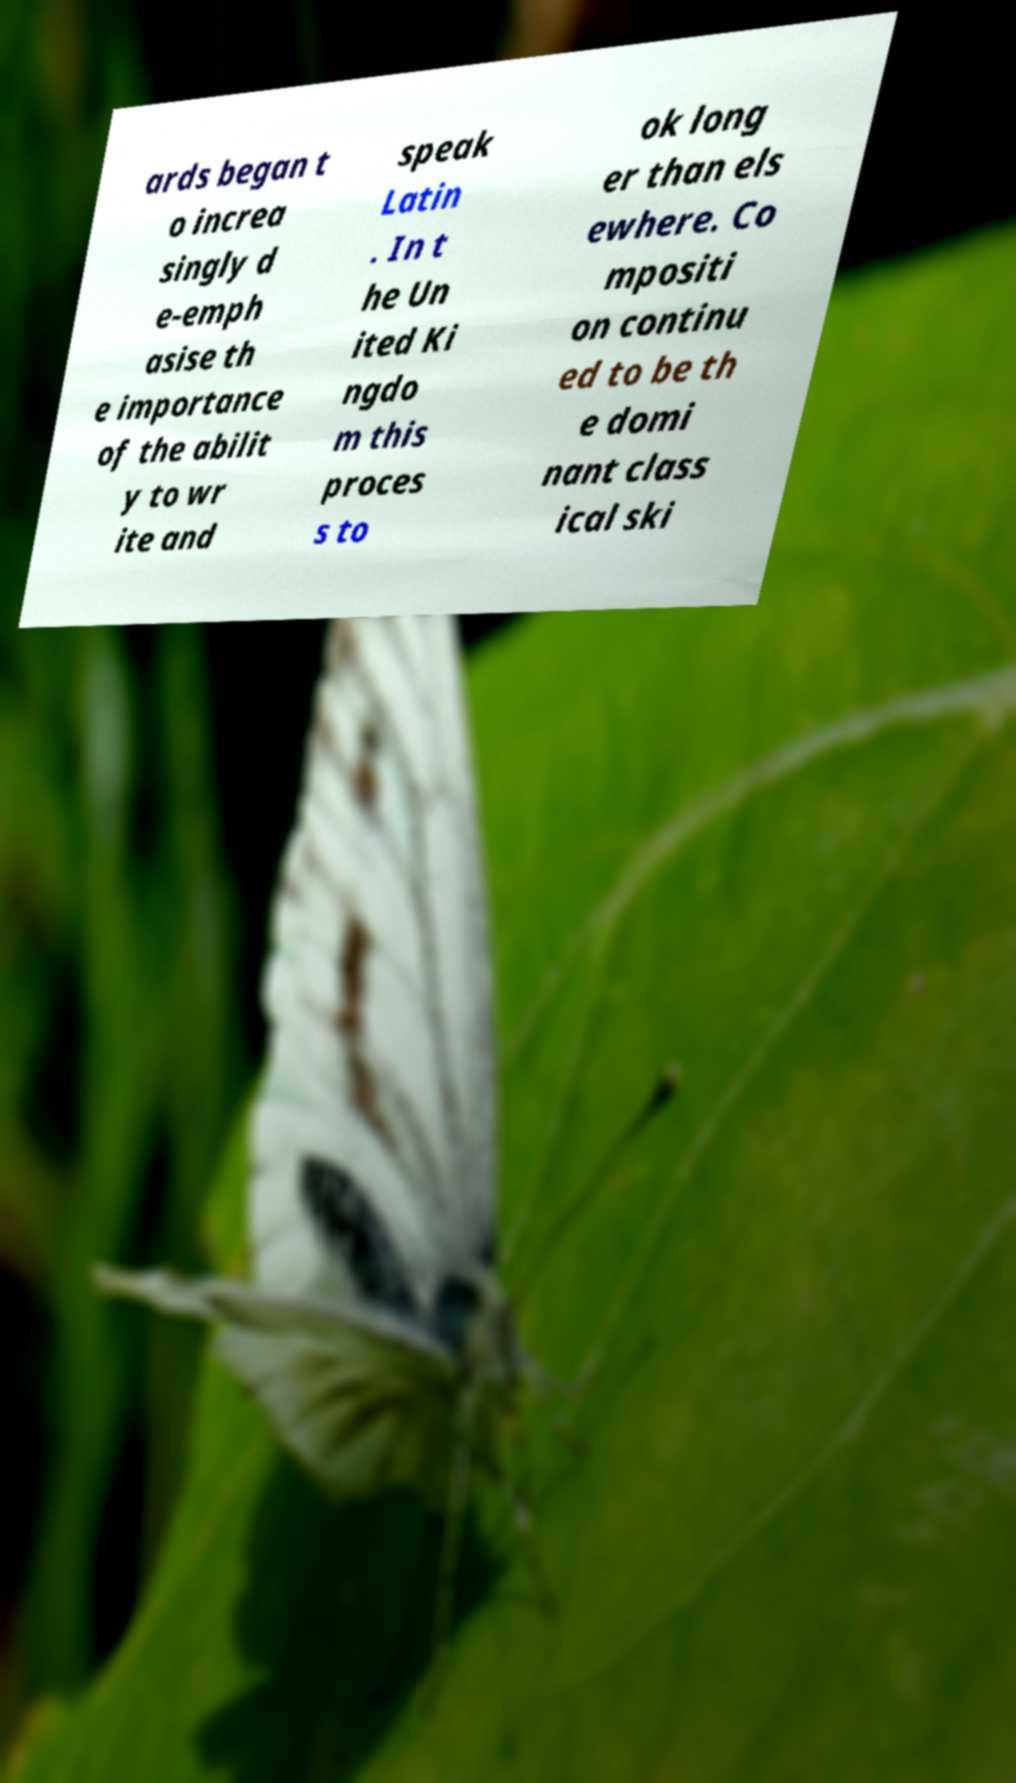Could you assist in decoding the text presented in this image and type it out clearly? ards began t o increa singly d e-emph asise th e importance of the abilit y to wr ite and speak Latin . In t he Un ited Ki ngdo m this proces s to ok long er than els ewhere. Co mpositi on continu ed to be th e domi nant class ical ski 